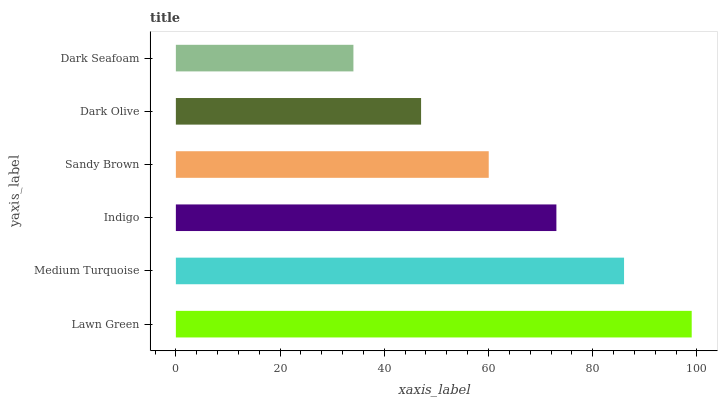Is Dark Seafoam the minimum?
Answer yes or no. Yes. Is Lawn Green the maximum?
Answer yes or no. Yes. Is Medium Turquoise the minimum?
Answer yes or no. No. Is Medium Turquoise the maximum?
Answer yes or no. No. Is Lawn Green greater than Medium Turquoise?
Answer yes or no. Yes. Is Medium Turquoise less than Lawn Green?
Answer yes or no. Yes. Is Medium Turquoise greater than Lawn Green?
Answer yes or no. No. Is Lawn Green less than Medium Turquoise?
Answer yes or no. No. Is Indigo the high median?
Answer yes or no. Yes. Is Sandy Brown the low median?
Answer yes or no. Yes. Is Dark Seafoam the high median?
Answer yes or no. No. Is Dark Olive the low median?
Answer yes or no. No. 